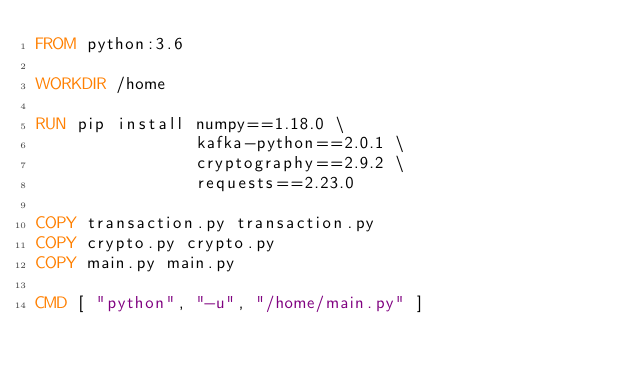<code> <loc_0><loc_0><loc_500><loc_500><_Dockerfile_>FROM python:3.6

WORKDIR /home

RUN pip install numpy==1.18.0 \
                kafka-python==2.0.1 \
                cryptography==2.9.2 \
                requests==2.23.0

COPY transaction.py transaction.py
COPY crypto.py crypto.py
COPY main.py main.py

CMD [ "python", "-u", "/home/main.py" ]</code> 